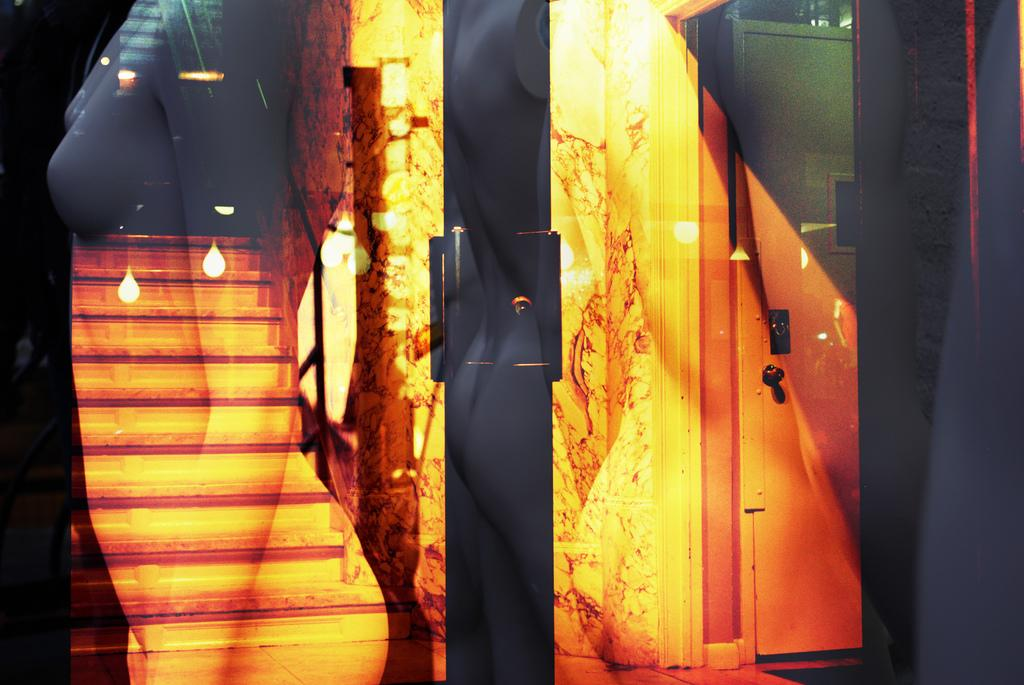What is one of the main features of the image? There is a door in the image. What else can be seen in the image? There are lights in the image. What type of rice is being cooked in the image? There is no rice present in the image; it only features a door and lights. How many babies are visible in the image? There are no babies present in the image; it only features a door and lights. 